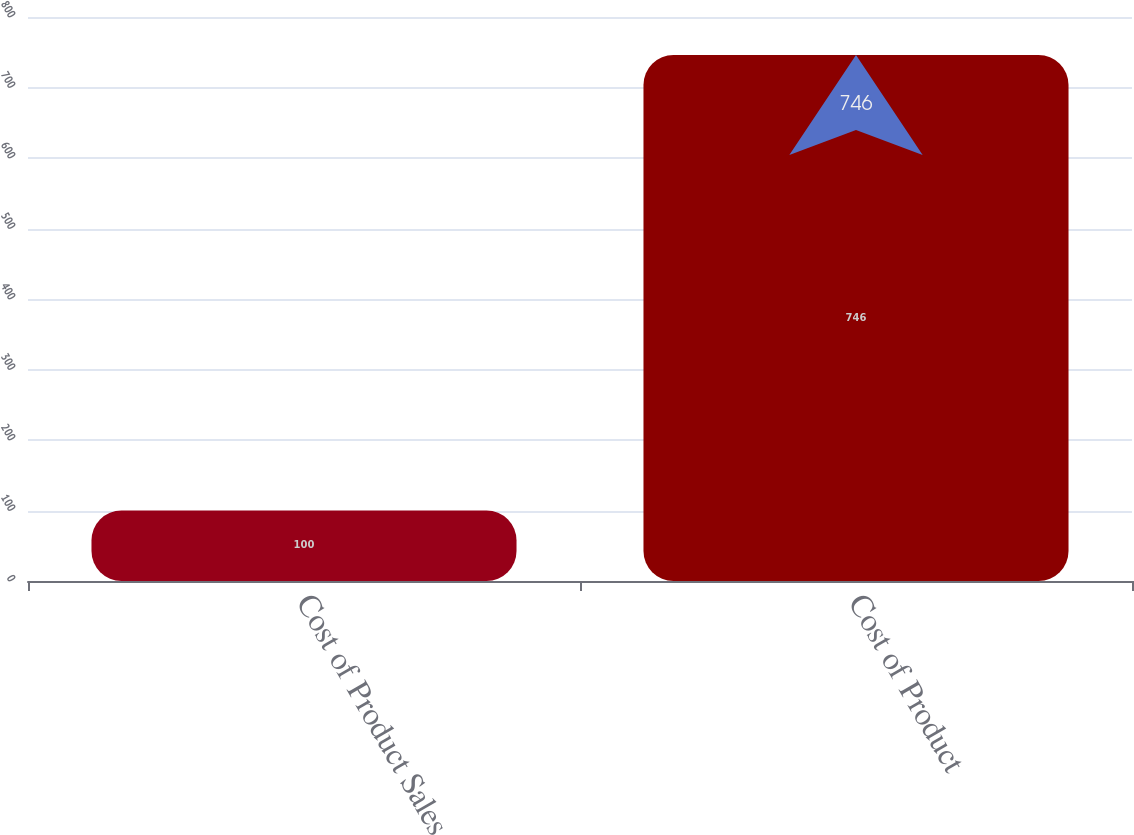<chart> <loc_0><loc_0><loc_500><loc_500><bar_chart><fcel>Cost of Product Sales<fcel>Cost of Product<nl><fcel>100<fcel>746<nl></chart> 